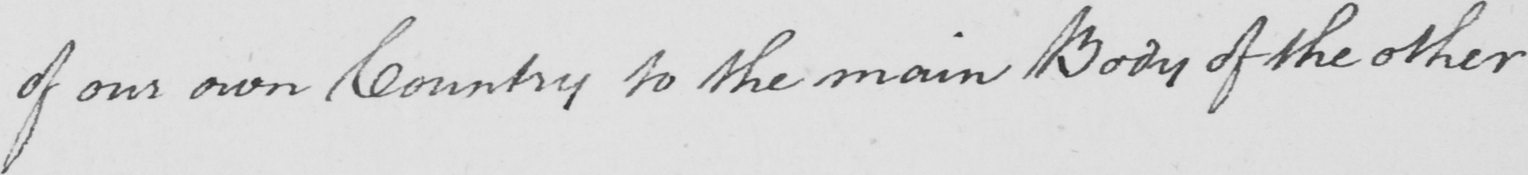Please provide the text content of this handwritten line. of our own Country to the main Body of the other 